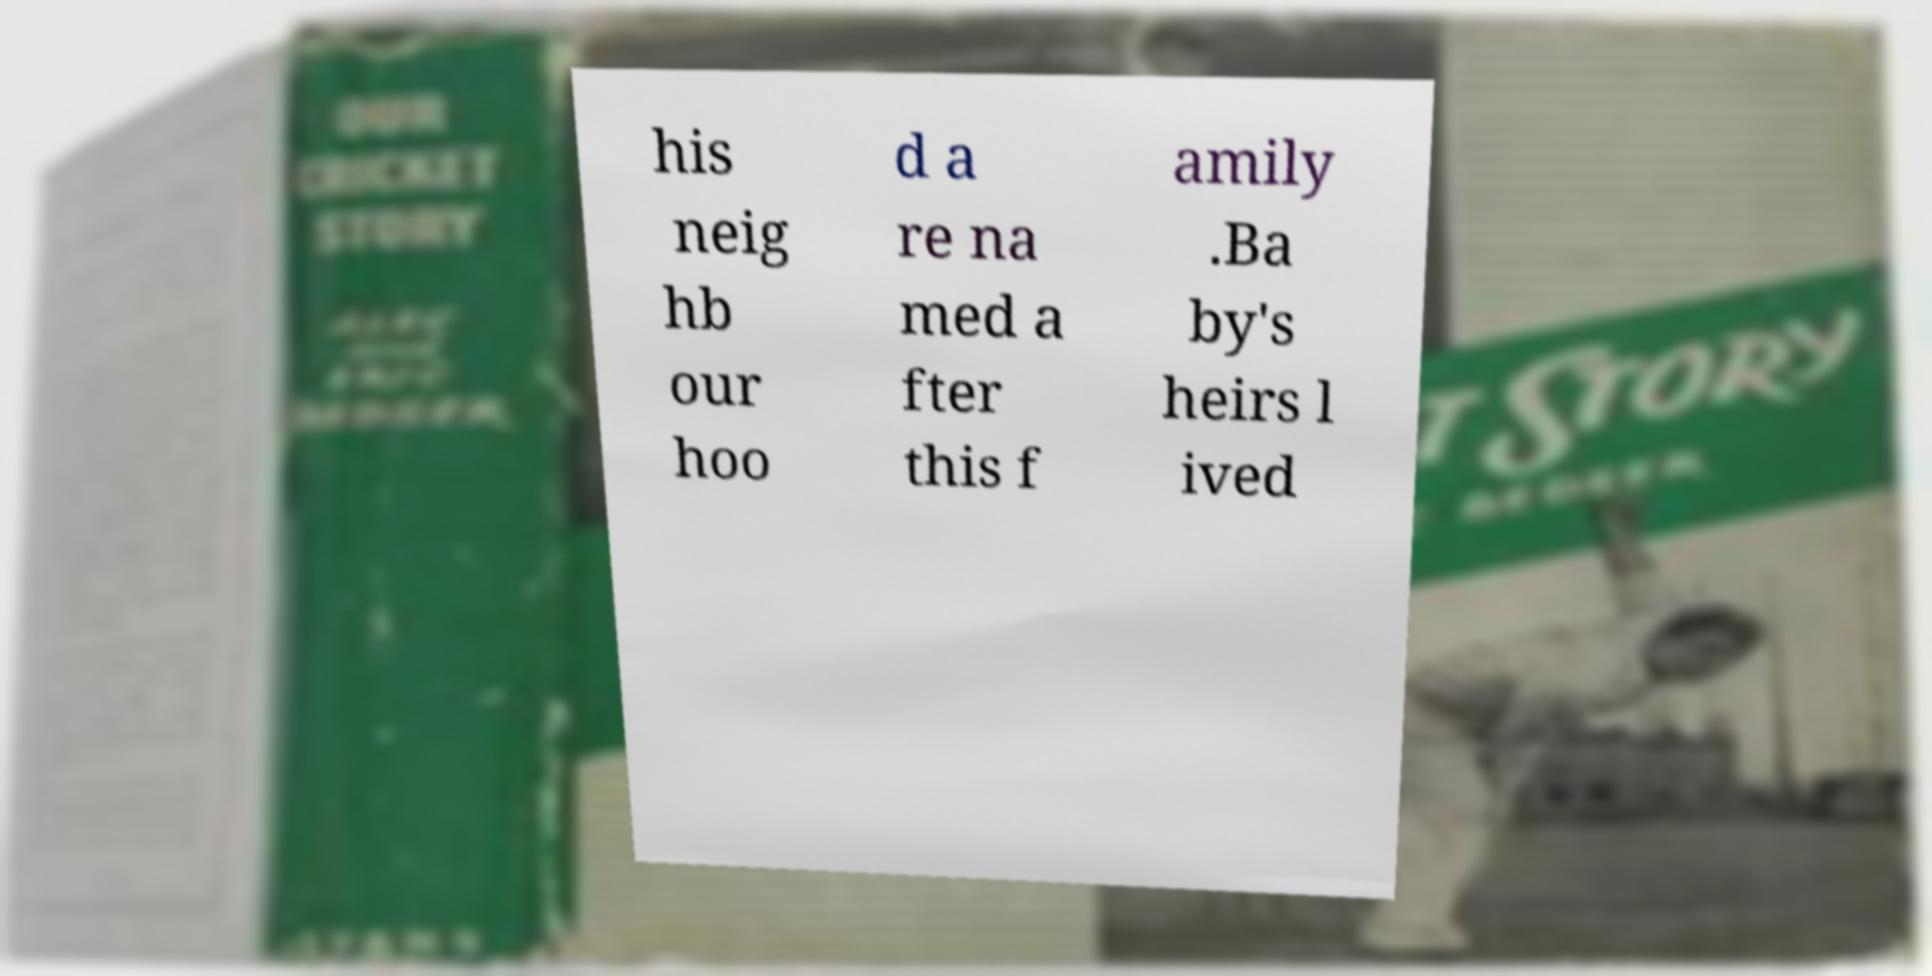Could you extract and type out the text from this image? his neig hb our hoo d a re na med a fter this f amily .Ba by's heirs l ived 